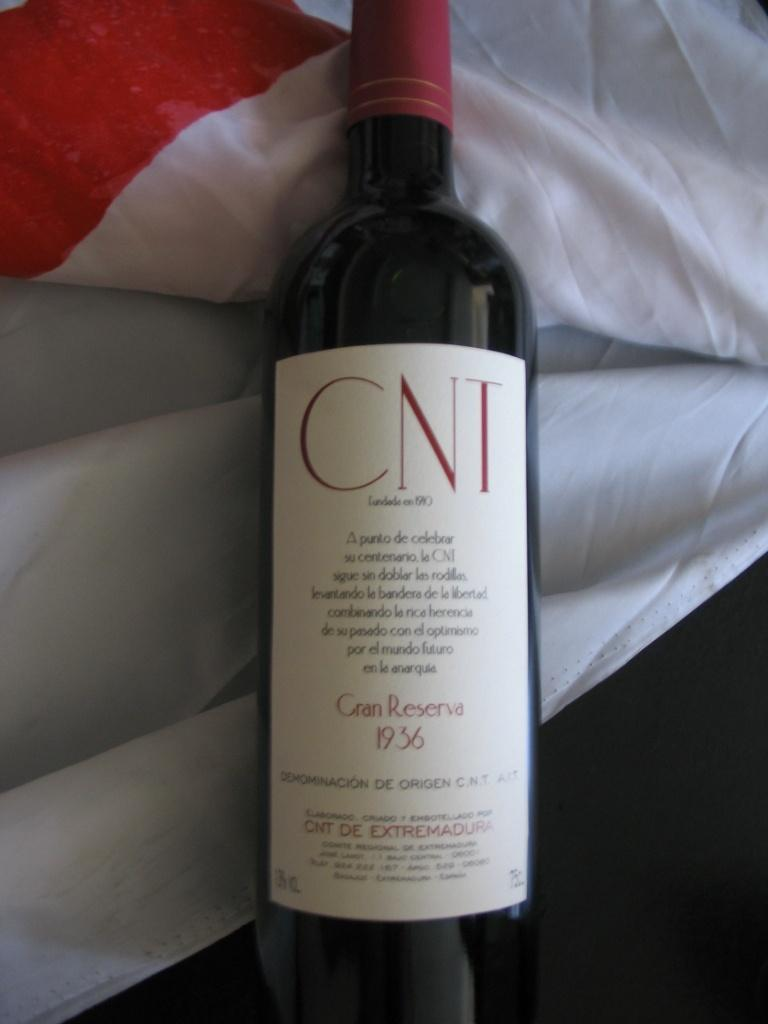<image>
Offer a succinct explanation of the picture presented. A bottle of Cran Reserva displays the date of 1936. 